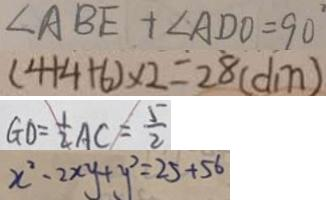<formula> <loc_0><loc_0><loc_500><loc_500>\angle A B E + \angle A D O = 9 0 ^ { \circ } 
 ( 4 + 4 + 6 ) \times 2 = 2 8 ( d m ) 
 G O = \frac { 1 } { 2 } A C = \frac { 5 } { 2 } 
 x ^ { 2 } - 2 x y + y ^ { 2 } = 2 5 + 5 6</formula> 